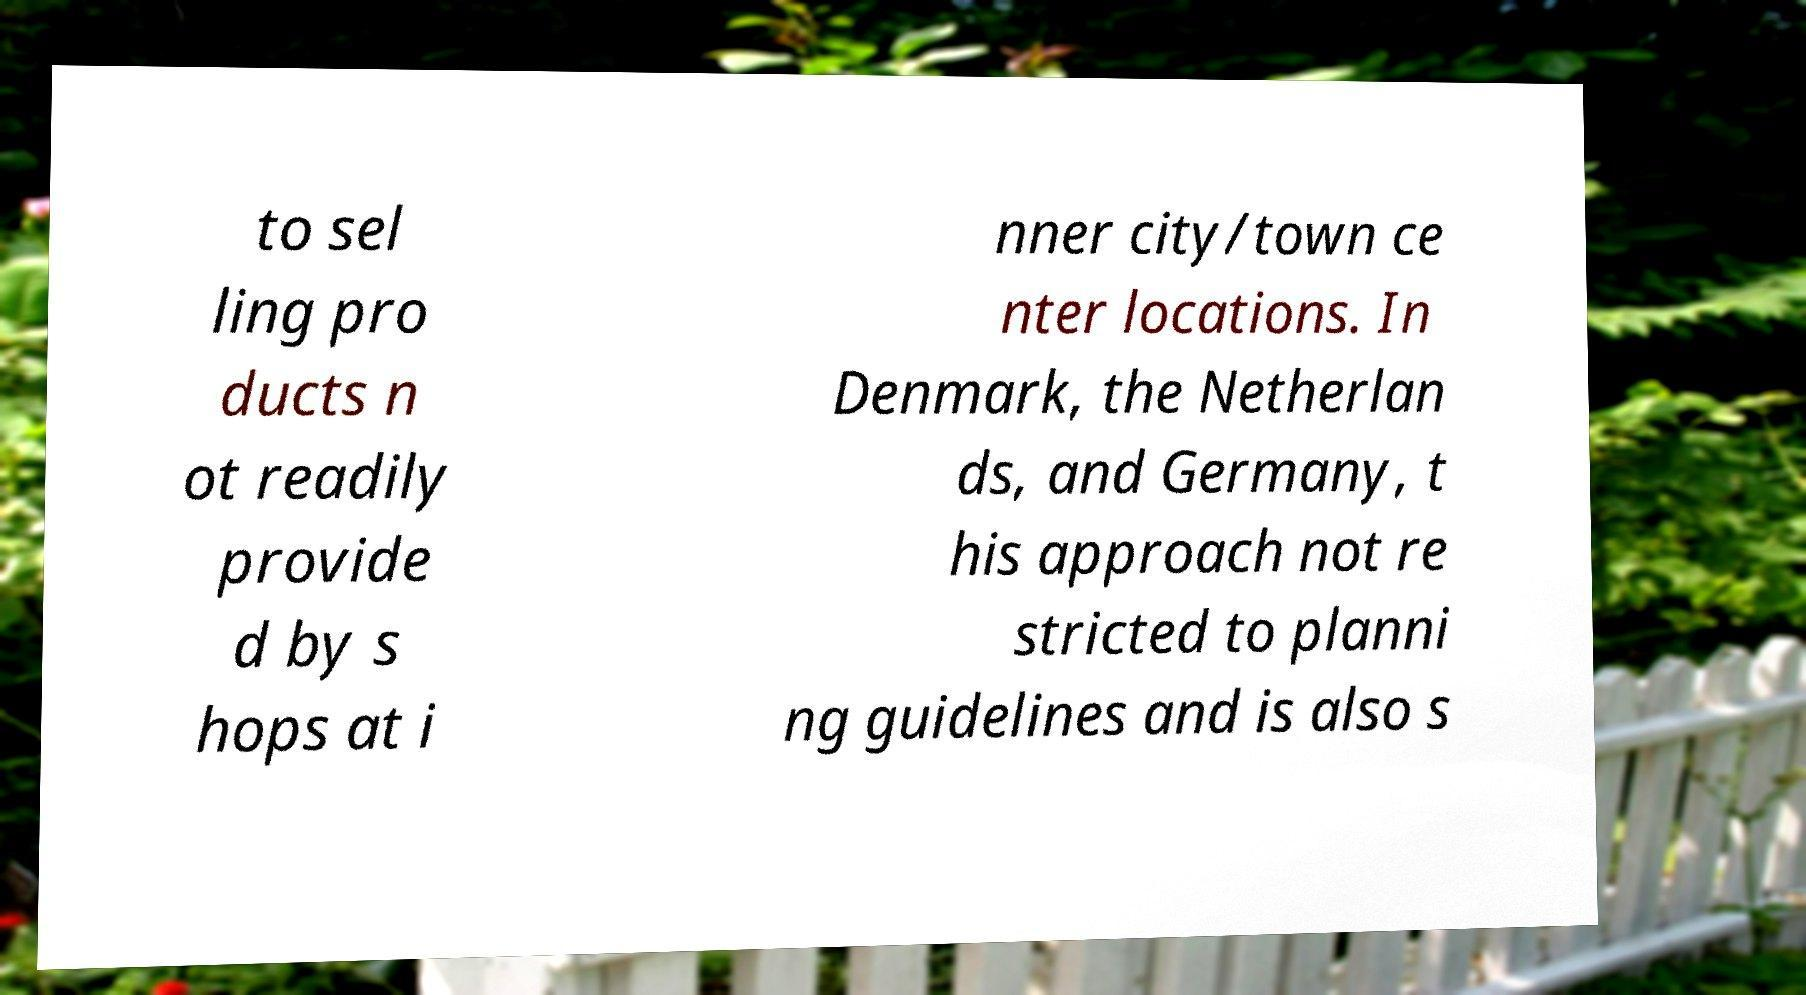Please identify and transcribe the text found in this image. to sel ling pro ducts n ot readily provide d by s hops at i nner city/town ce nter locations. In Denmark, the Netherlan ds, and Germany, t his approach not re stricted to planni ng guidelines and is also s 